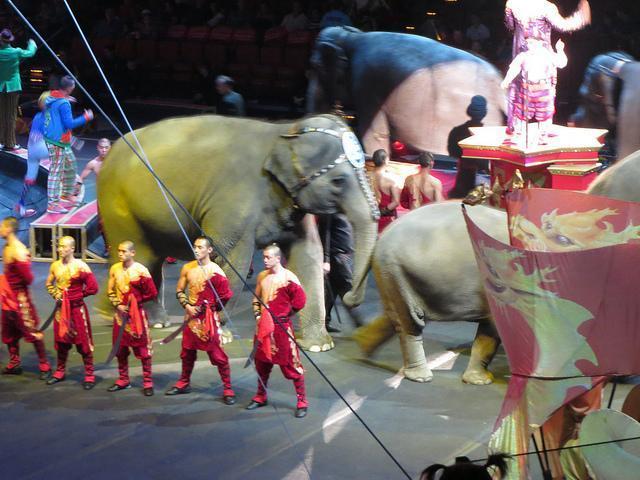How many elephants are there?
Give a very brief answer. 5. How many elephants are in the photo?
Give a very brief answer. 4. How many people are visible?
Give a very brief answer. 8. How many orange lights can you see on the motorcycle?
Give a very brief answer. 0. 